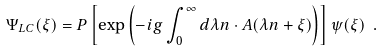Convert formula to latex. <formula><loc_0><loc_0><loc_500><loc_500>\Psi _ { L C } ( \xi ) = { P } \left [ \exp \left ( - i g \int ^ { \infty } _ { 0 } d \lambda n \cdot A ( \lambda n + \xi ) \right ) \right ] \psi ( \xi ) \ .</formula> 